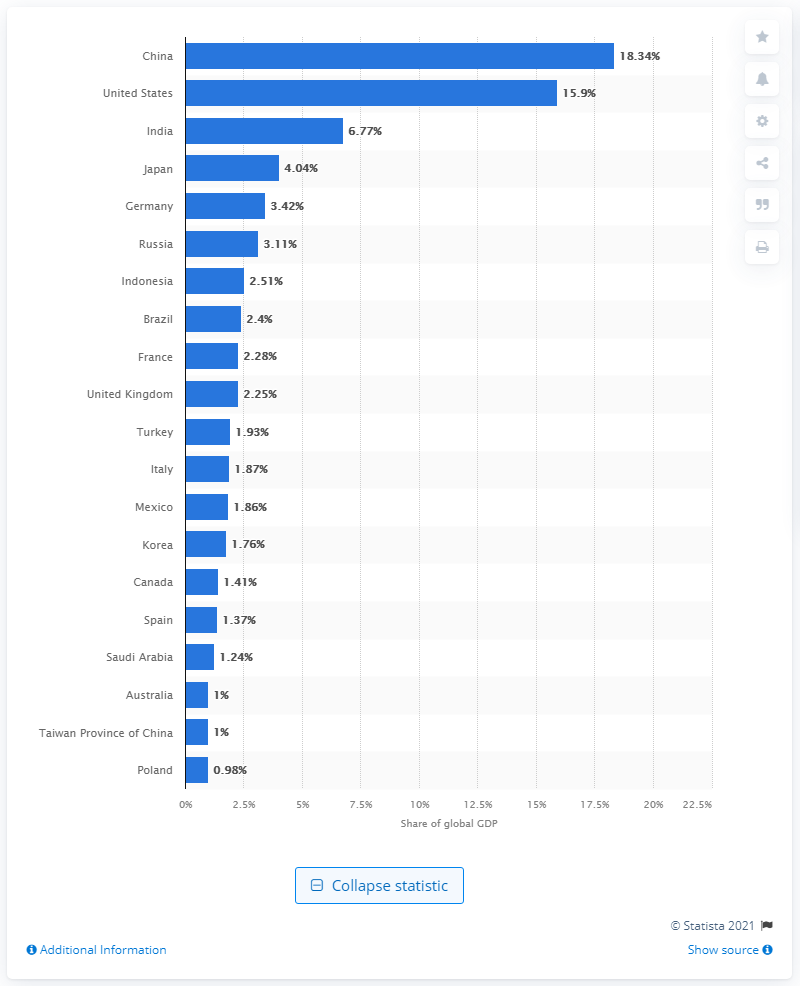Outline some significant characteristics in this image. In 2020, Germany accounted for approximately 29.2% of the global GDP. 